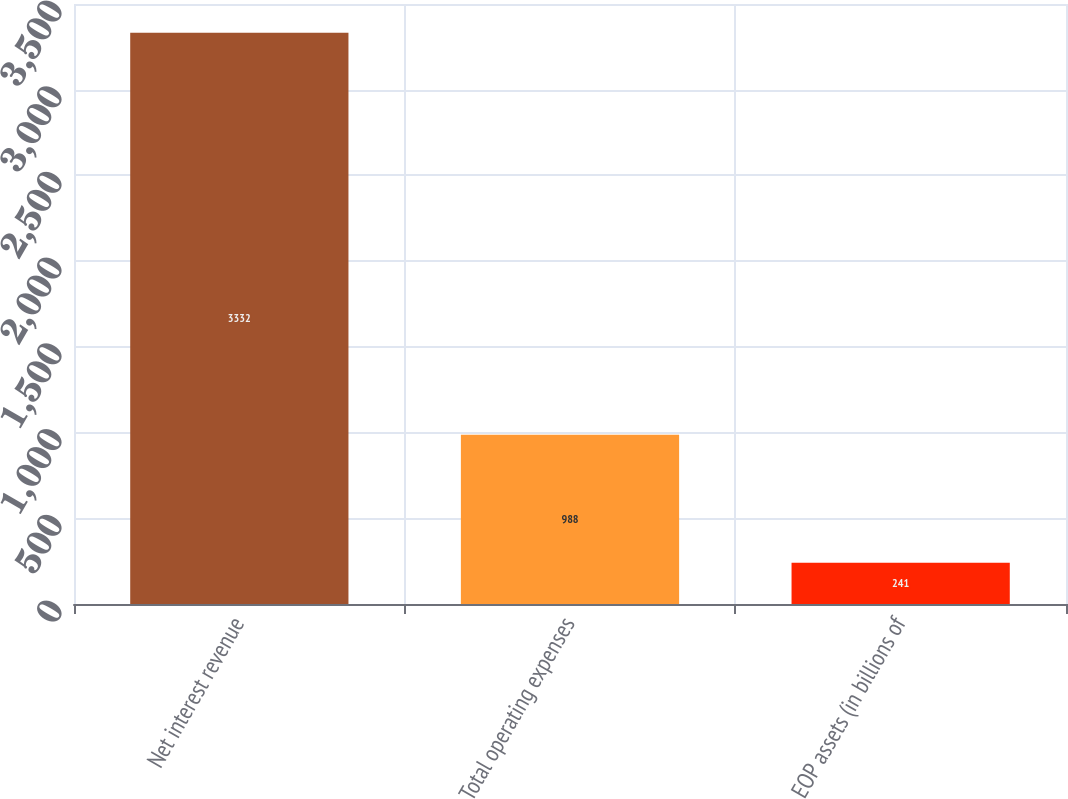Convert chart. <chart><loc_0><loc_0><loc_500><loc_500><bar_chart><fcel>Net interest revenue<fcel>Total operating expenses<fcel>EOP assets (in billions of<nl><fcel>3332<fcel>988<fcel>241<nl></chart> 